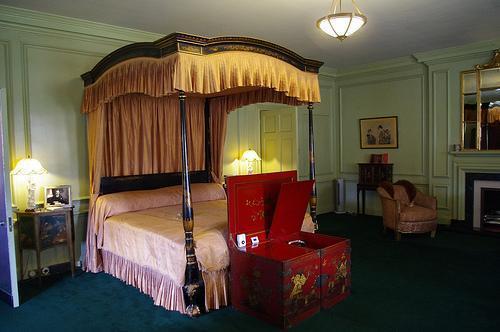How many posts does the bed have?
Give a very brief answer. 4. How many lamps are by the bed?
Give a very brief answer. 2. How many beds are there?
Give a very brief answer. 1. 